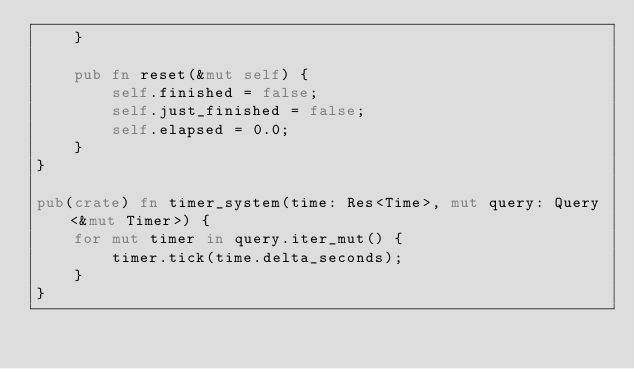<code> <loc_0><loc_0><loc_500><loc_500><_Rust_>    }

    pub fn reset(&mut self) {
        self.finished = false;
        self.just_finished = false;
        self.elapsed = 0.0;
    }
}

pub(crate) fn timer_system(time: Res<Time>, mut query: Query<&mut Timer>) {
    for mut timer in query.iter_mut() {
        timer.tick(time.delta_seconds);
    }
}
</code> 